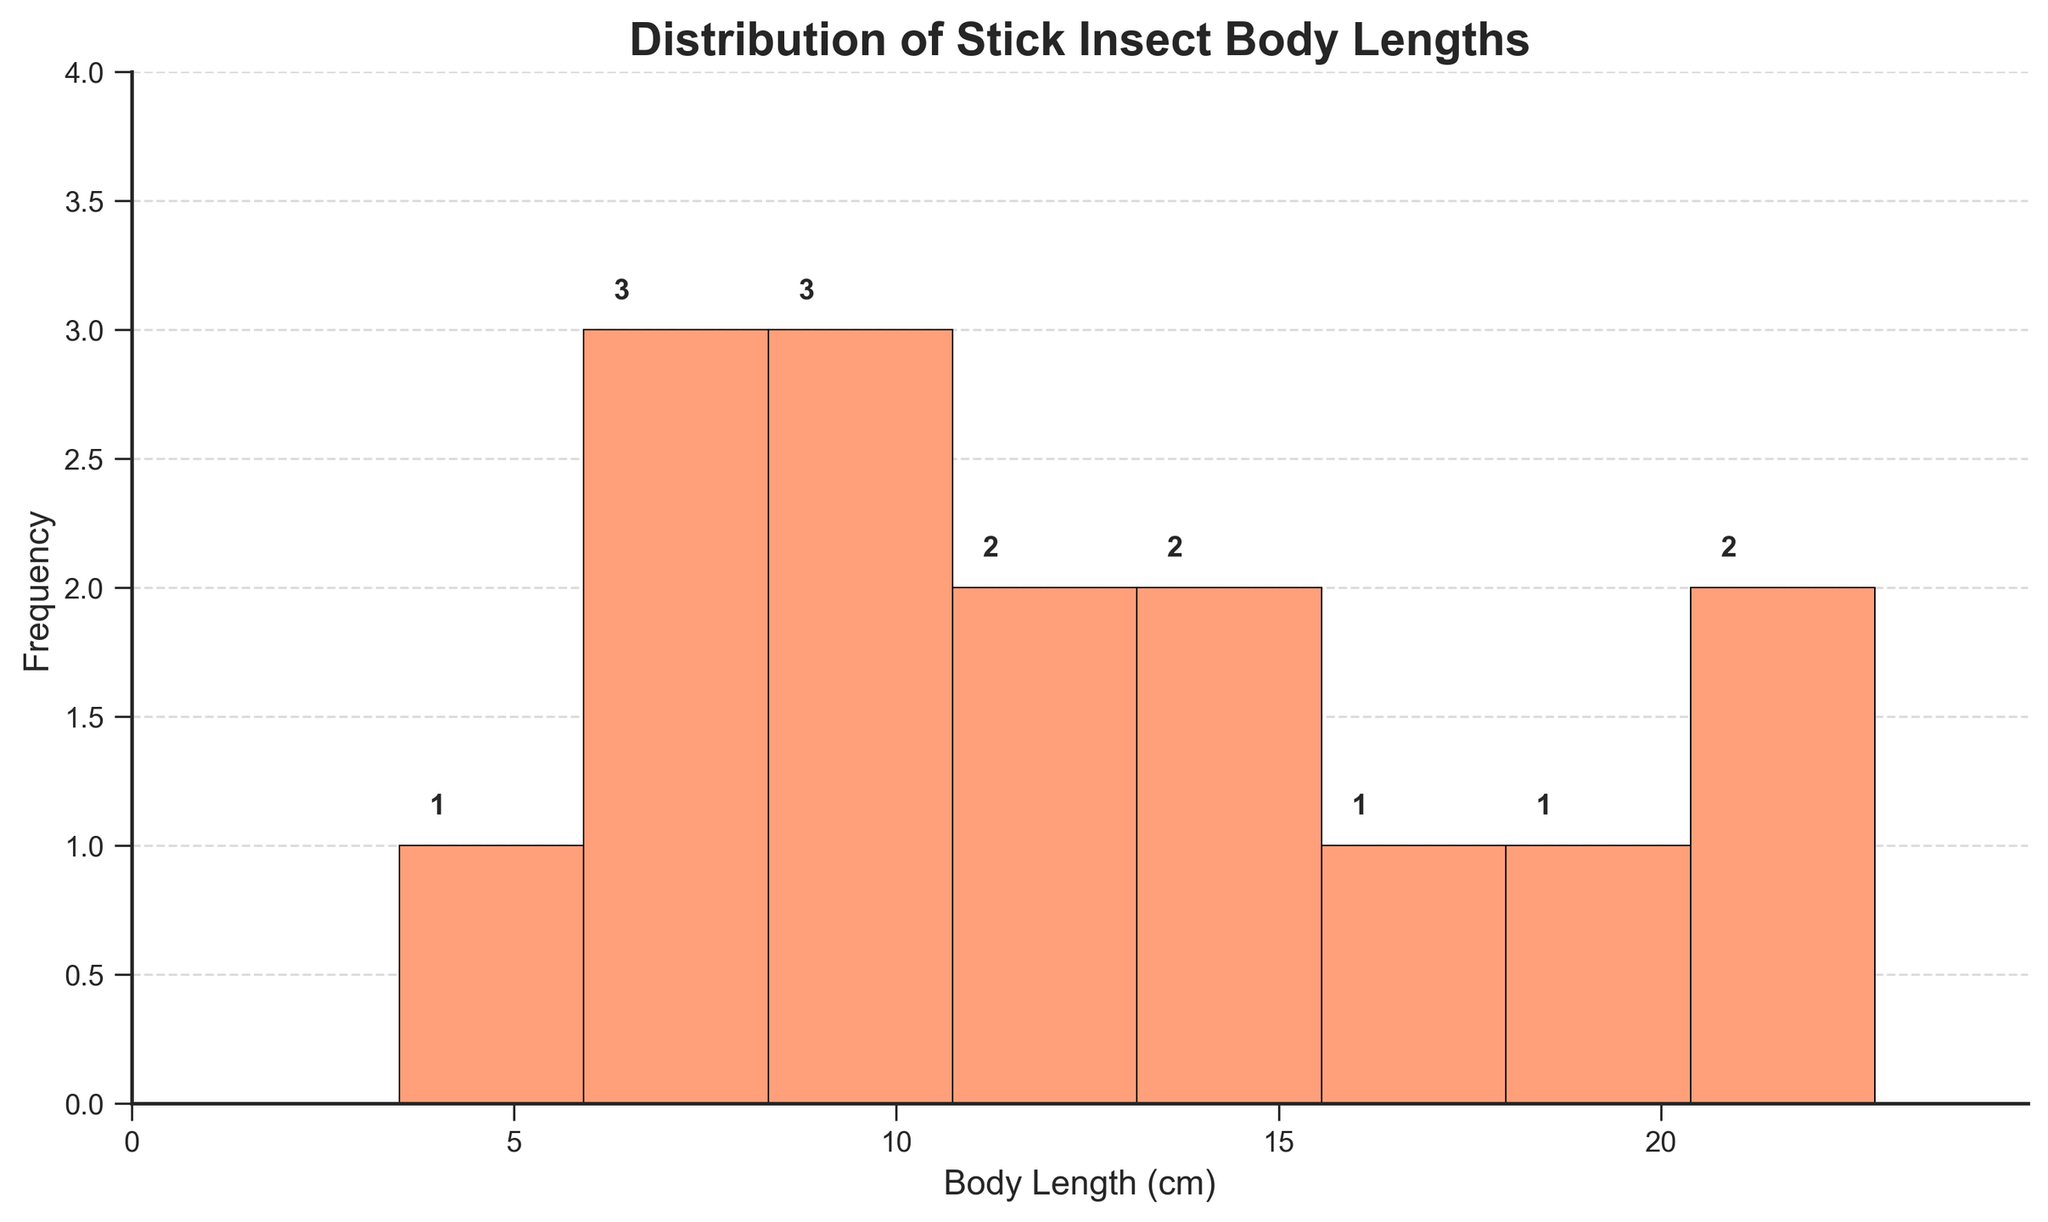What is the title of the histogram? The title is displayed at the top of the figure and typically summarizes the content.
Answer: Distribution of Stick Insect Body Lengths What is the body length range with the highest frequency of stick insects? Observe the bin with the highest bar on the histogram, indicating the most frequent range of body lengths.
Answer: 6-9 cm How many bins are there in the histogram? Count the number of bars or sections in the histogram.
Answer: 8 What is the body length range with the lowest frequency of stick insects? Look for the bin with the shortest bar, indicating the least frequent range of body lengths.
Answer: 3-6 cm Which species of stick insects can be found in the range of 15-18 cm body length? Refer to the data table to identify species within the indicated range.
Answer: Extatosoma tiaratum and Lonchodes brevipes How many stick insects have a body length between 9 and 12 cm? Count the stick insects within the 9-12 cm range from the histogram.
Answer: 4 Compare the number of stick insects in the 6-9 cm range to those in the 12-15 cm range. Which is more frequent? Compare the height of bars in the histogram for these two ranges.
Answer: 6-9 cm What is the median body length of the stick insects? To find the median, list all body lengths in order and identify the middle value.
Answer: 10.6 cm What are the minimum and maximum body lengths of the stick insects in the collection? Identify the smallest and largest values from the data.
Answer: 3.5 cm and 22.8 cm How does the frequency of insects in the 18-21 cm range compare to those in the 21-24 cm range? Compare the heights of the respective bars in the histogram.
Answer: 18-21 cm has more than 21-24 cm 